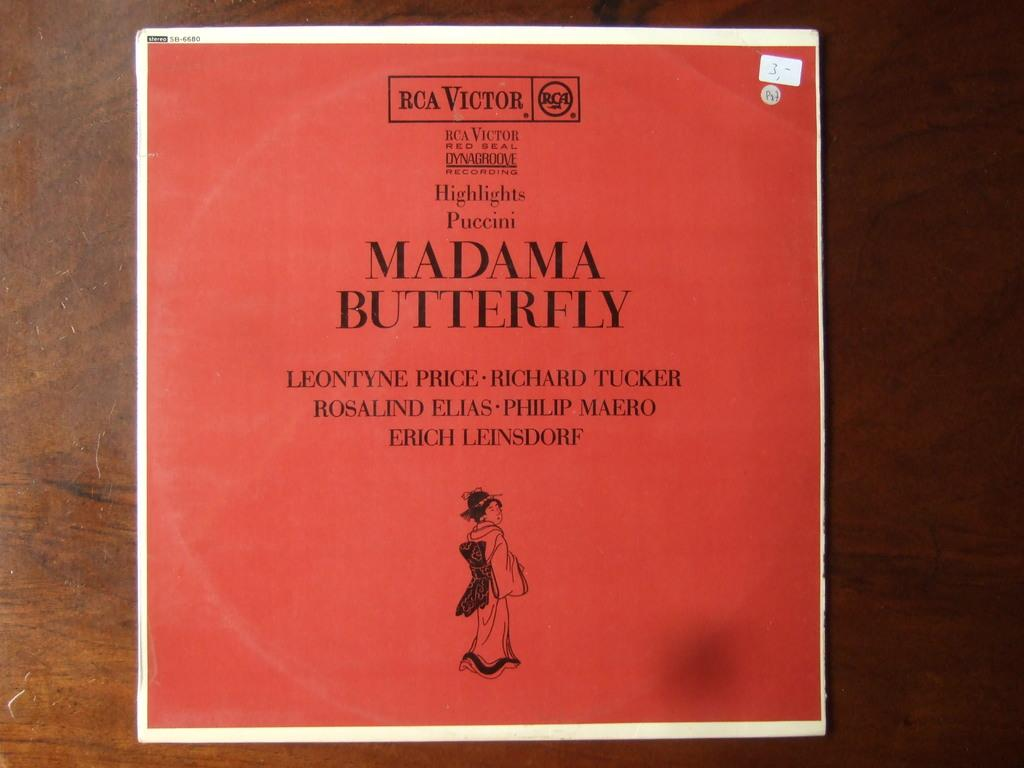Provide a one-sentence caption for the provided image. A red document with MAdama Butterfly written on it. 